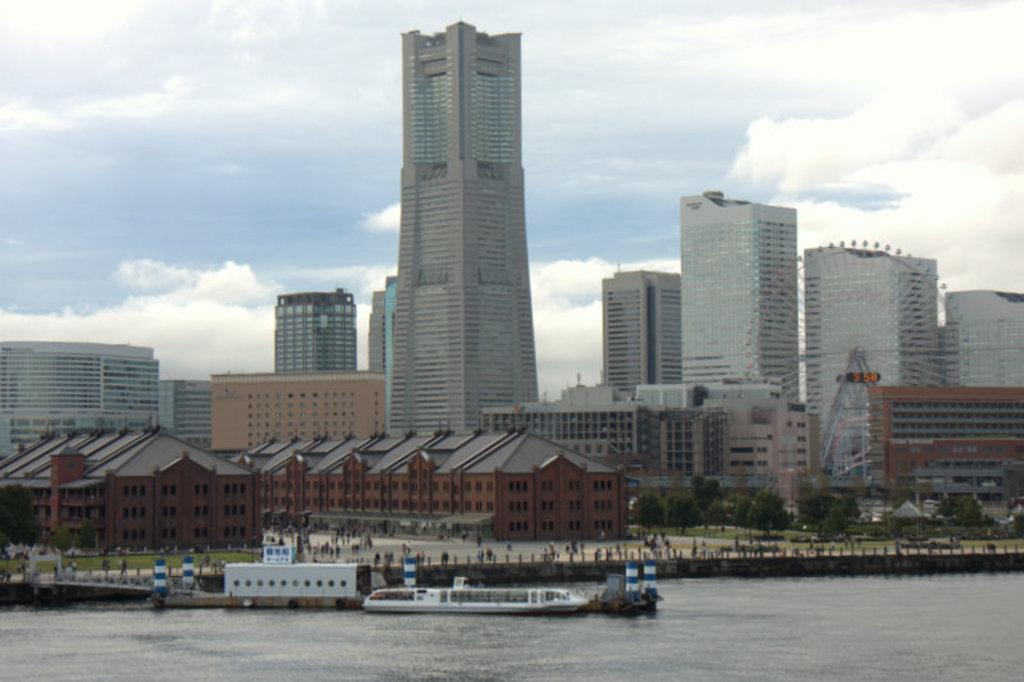What type of structures can be seen in the image? There are buildings in the image. What feature is visible on the buildings? There are windows visible in the image. What type of natural elements can be seen in the image? There are trees and water visible in the image. Are there any living beings present in the image? Yes, there are people in the image. Can you describe the water in the image? The water is present in the image. What is the color of the sky in the image? The sky is blue and white in color. What type of beef is being served in harmony with the engine in the image? There is no beef, harmony, or engine present in the image. 